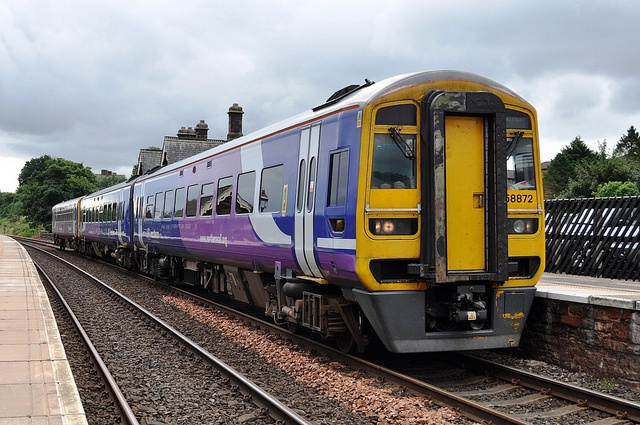Describe the objects in this image and their specific colors. I can see train in white, black, gray, darkgray, and olive tones and car in white, black, gray, and darkgray tones in this image. 